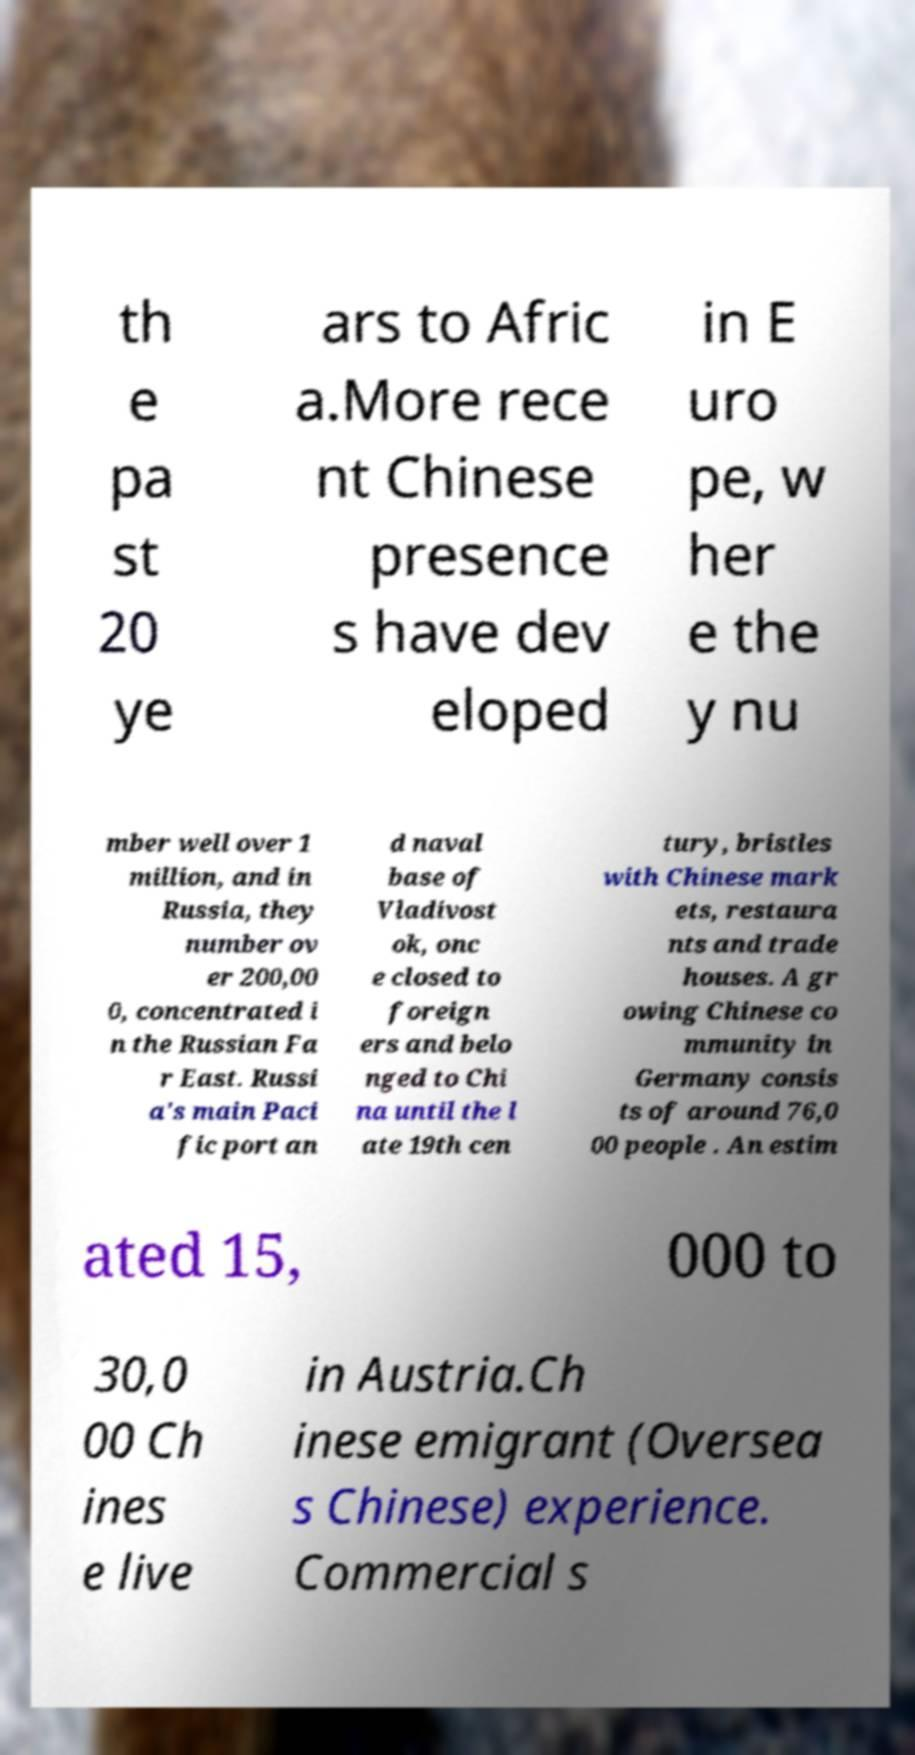Could you extract and type out the text from this image? th e pa st 20 ye ars to Afric a.More rece nt Chinese presence s have dev eloped in E uro pe, w her e the y nu mber well over 1 million, and in Russia, they number ov er 200,00 0, concentrated i n the Russian Fa r East. Russi a's main Paci fic port an d naval base of Vladivost ok, onc e closed to foreign ers and belo nged to Chi na until the l ate 19th cen tury, bristles with Chinese mark ets, restaura nts and trade houses. A gr owing Chinese co mmunity in Germany consis ts of around 76,0 00 people . An estim ated 15, 000 to 30,0 00 Ch ines e live in Austria.Ch inese emigrant (Oversea s Chinese) experience. Commercial s 